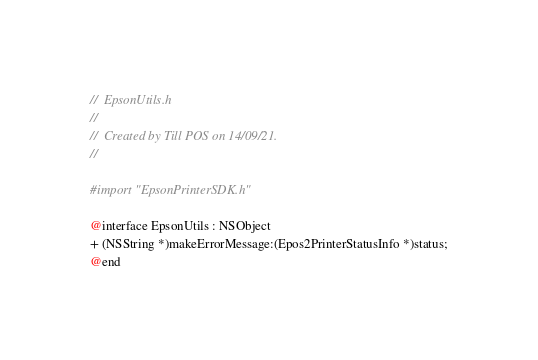<code> <loc_0><loc_0><loc_500><loc_500><_C_>//  EpsonUtils.h
//
//  Created by Till POS on 14/09/21.
//

#import "EpsonPrinterSDK.h"

@interface EpsonUtils : NSObject
+ (NSString *)makeErrorMessage:(Epos2PrinterStatusInfo *)status;
@end
</code> 